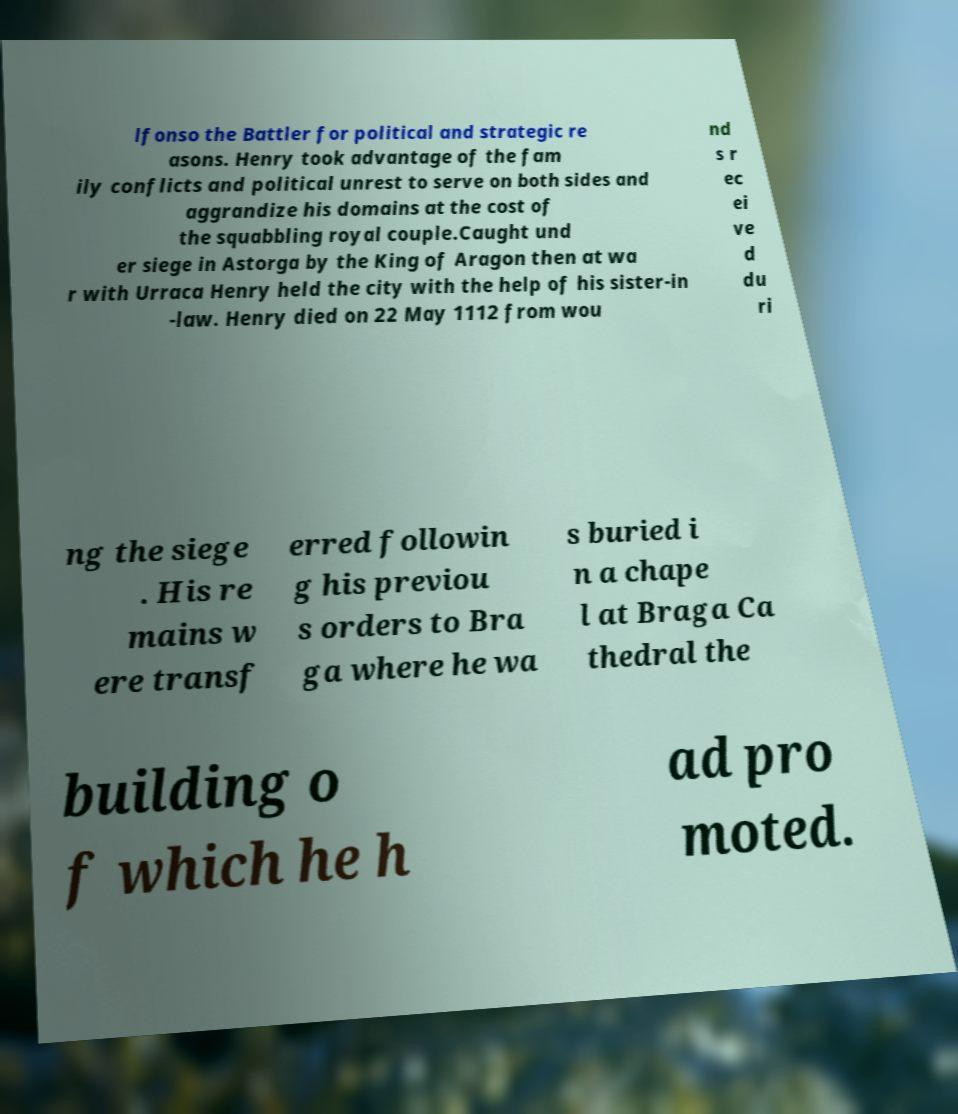Could you assist in decoding the text presented in this image and type it out clearly? lfonso the Battler for political and strategic re asons. Henry took advantage of the fam ily conflicts and political unrest to serve on both sides and aggrandize his domains at the cost of the squabbling royal couple.Caught und er siege in Astorga by the King of Aragon then at wa r with Urraca Henry held the city with the help of his sister-in -law. Henry died on 22 May 1112 from wou nd s r ec ei ve d du ri ng the siege . His re mains w ere transf erred followin g his previou s orders to Bra ga where he wa s buried i n a chape l at Braga Ca thedral the building o f which he h ad pro moted. 